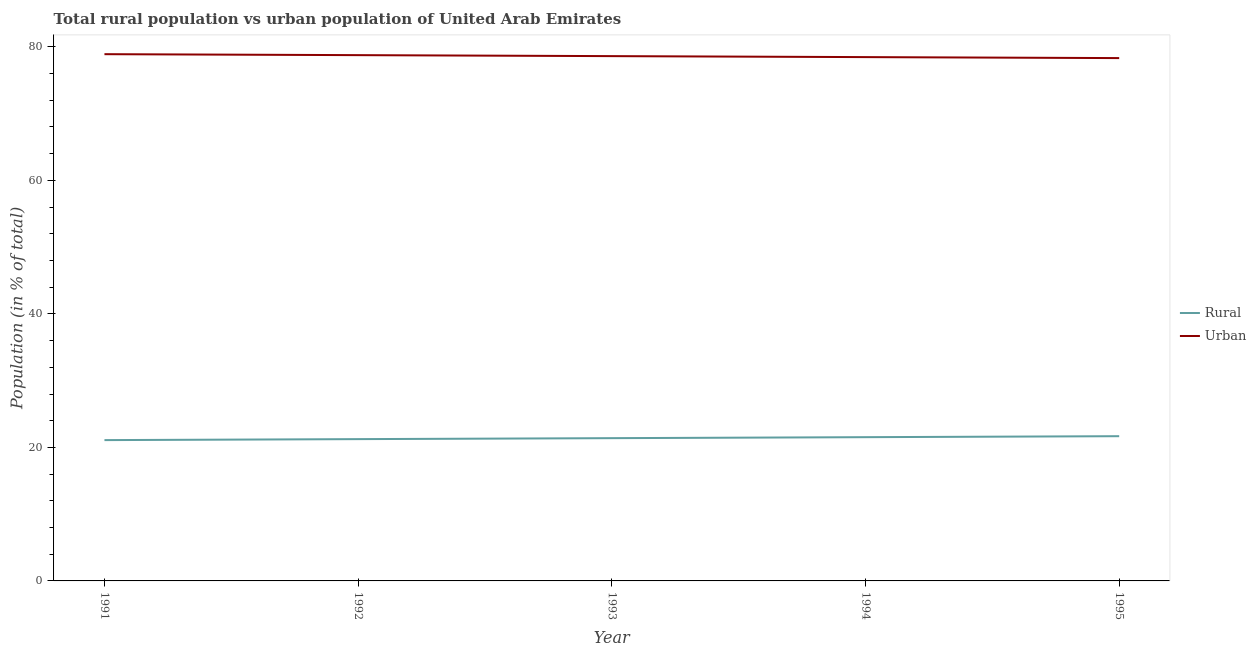What is the urban population in 1993?
Provide a succinct answer. 78.61. Across all years, what is the maximum urban population?
Your response must be concise. 78.91. Across all years, what is the minimum urban population?
Offer a very short reply. 78.32. In which year was the urban population maximum?
Provide a short and direct response. 1991. What is the total rural population in the graph?
Your answer should be very brief. 106.93. What is the difference between the urban population in 1991 and that in 1995?
Offer a terse response. 0.59. What is the difference between the rural population in 1991 and the urban population in 1993?
Your answer should be compact. -57.52. What is the average urban population per year?
Offer a very short reply. 78.61. In the year 1994, what is the difference between the urban population and rural population?
Offer a very short reply. 56.93. In how many years, is the urban population greater than 76 %?
Keep it short and to the point. 5. What is the ratio of the rural population in 1993 to that in 1995?
Ensure brevity in your answer.  0.99. Is the difference between the urban population in 1991 and 1992 greater than the difference between the rural population in 1991 and 1992?
Make the answer very short. Yes. What is the difference between the highest and the second highest urban population?
Provide a succinct answer. 0.15. What is the difference between the highest and the lowest rural population?
Offer a terse response. 0.59. In how many years, is the rural population greater than the average rural population taken over all years?
Keep it short and to the point. 2. Does the rural population monotonically increase over the years?
Provide a succinct answer. Yes. Is the rural population strictly greater than the urban population over the years?
Provide a succinct answer. No. How many lines are there?
Provide a short and direct response. 2. How many years are there in the graph?
Your response must be concise. 5. What is the difference between two consecutive major ticks on the Y-axis?
Give a very brief answer. 20. Are the values on the major ticks of Y-axis written in scientific E-notation?
Your response must be concise. No. Where does the legend appear in the graph?
Keep it short and to the point. Center right. What is the title of the graph?
Provide a short and direct response. Total rural population vs urban population of United Arab Emirates. What is the label or title of the Y-axis?
Your response must be concise. Population (in % of total). What is the Population (in % of total) of Rural in 1991?
Give a very brief answer. 21.09. What is the Population (in % of total) in Urban in 1991?
Your response must be concise. 78.91. What is the Population (in % of total) in Rural in 1992?
Offer a terse response. 21.24. What is the Population (in % of total) in Urban in 1992?
Your answer should be very brief. 78.76. What is the Population (in % of total) of Rural in 1993?
Keep it short and to the point. 21.39. What is the Population (in % of total) in Urban in 1993?
Your response must be concise. 78.61. What is the Population (in % of total) of Rural in 1994?
Offer a very short reply. 21.53. What is the Population (in % of total) in Urban in 1994?
Offer a very short reply. 78.47. What is the Population (in % of total) in Rural in 1995?
Your response must be concise. 21.68. What is the Population (in % of total) of Urban in 1995?
Ensure brevity in your answer.  78.32. Across all years, what is the maximum Population (in % of total) of Rural?
Provide a short and direct response. 21.68. Across all years, what is the maximum Population (in % of total) of Urban?
Keep it short and to the point. 78.91. Across all years, what is the minimum Population (in % of total) of Rural?
Provide a succinct answer. 21.09. Across all years, what is the minimum Population (in % of total) in Urban?
Your answer should be compact. 78.32. What is the total Population (in % of total) in Rural in the graph?
Your response must be concise. 106.93. What is the total Population (in % of total) in Urban in the graph?
Provide a succinct answer. 393.07. What is the difference between the Population (in % of total) in Rural in 1991 and that in 1992?
Make the answer very short. -0.15. What is the difference between the Population (in % of total) in Urban in 1991 and that in 1992?
Offer a very short reply. 0.15. What is the difference between the Population (in % of total) in Rural in 1991 and that in 1993?
Your answer should be compact. -0.29. What is the difference between the Population (in % of total) of Urban in 1991 and that in 1993?
Give a very brief answer. 0.29. What is the difference between the Population (in % of total) in Rural in 1991 and that in 1994?
Offer a very short reply. -0.44. What is the difference between the Population (in % of total) in Urban in 1991 and that in 1994?
Your response must be concise. 0.44. What is the difference between the Population (in % of total) in Rural in 1991 and that in 1995?
Provide a short and direct response. -0.59. What is the difference between the Population (in % of total) of Urban in 1991 and that in 1995?
Provide a short and direct response. 0.59. What is the difference between the Population (in % of total) of Rural in 1992 and that in 1993?
Offer a very short reply. -0.15. What is the difference between the Population (in % of total) in Urban in 1992 and that in 1993?
Your answer should be compact. 0.15. What is the difference between the Population (in % of total) in Rural in 1992 and that in 1994?
Your answer should be compact. -0.29. What is the difference between the Population (in % of total) in Urban in 1992 and that in 1994?
Provide a succinct answer. 0.29. What is the difference between the Population (in % of total) in Rural in 1992 and that in 1995?
Give a very brief answer. -0.44. What is the difference between the Population (in % of total) in Urban in 1992 and that in 1995?
Offer a terse response. 0.44. What is the difference between the Population (in % of total) of Rural in 1993 and that in 1994?
Give a very brief answer. -0.15. What is the difference between the Population (in % of total) of Urban in 1993 and that in 1994?
Ensure brevity in your answer.  0.15. What is the difference between the Population (in % of total) of Rural in 1993 and that in 1995?
Ensure brevity in your answer.  -0.29. What is the difference between the Population (in % of total) in Urban in 1993 and that in 1995?
Your answer should be compact. 0.29. What is the difference between the Population (in % of total) of Rural in 1994 and that in 1995?
Keep it short and to the point. -0.15. What is the difference between the Population (in % of total) in Urban in 1994 and that in 1995?
Your response must be concise. 0.15. What is the difference between the Population (in % of total) in Rural in 1991 and the Population (in % of total) in Urban in 1992?
Give a very brief answer. -57.67. What is the difference between the Population (in % of total) of Rural in 1991 and the Population (in % of total) of Urban in 1993?
Offer a terse response. -57.52. What is the difference between the Population (in % of total) in Rural in 1991 and the Population (in % of total) in Urban in 1994?
Provide a short and direct response. -57.37. What is the difference between the Population (in % of total) of Rural in 1991 and the Population (in % of total) of Urban in 1995?
Make the answer very short. -57.23. What is the difference between the Population (in % of total) of Rural in 1992 and the Population (in % of total) of Urban in 1993?
Your answer should be compact. -57.37. What is the difference between the Population (in % of total) in Rural in 1992 and the Population (in % of total) in Urban in 1994?
Your response must be concise. -57.23. What is the difference between the Population (in % of total) in Rural in 1992 and the Population (in % of total) in Urban in 1995?
Offer a terse response. -57.08. What is the difference between the Population (in % of total) of Rural in 1993 and the Population (in % of total) of Urban in 1994?
Make the answer very short. -57.08. What is the difference between the Population (in % of total) of Rural in 1993 and the Population (in % of total) of Urban in 1995?
Ensure brevity in your answer.  -56.93. What is the difference between the Population (in % of total) in Rural in 1994 and the Population (in % of total) in Urban in 1995?
Your answer should be very brief. -56.79. What is the average Population (in % of total) in Rural per year?
Provide a short and direct response. 21.39. What is the average Population (in % of total) of Urban per year?
Ensure brevity in your answer.  78.61. In the year 1991, what is the difference between the Population (in % of total) in Rural and Population (in % of total) in Urban?
Offer a terse response. -57.81. In the year 1992, what is the difference between the Population (in % of total) of Rural and Population (in % of total) of Urban?
Ensure brevity in your answer.  -57.52. In the year 1993, what is the difference between the Population (in % of total) in Rural and Population (in % of total) in Urban?
Offer a terse response. -57.23. In the year 1994, what is the difference between the Population (in % of total) in Rural and Population (in % of total) in Urban?
Your answer should be compact. -56.93. In the year 1995, what is the difference between the Population (in % of total) of Rural and Population (in % of total) of Urban?
Offer a terse response. -56.64. What is the ratio of the Population (in % of total) in Rural in 1991 to that in 1993?
Give a very brief answer. 0.99. What is the ratio of the Population (in % of total) in Rural in 1991 to that in 1994?
Your answer should be very brief. 0.98. What is the ratio of the Population (in % of total) of Urban in 1991 to that in 1994?
Give a very brief answer. 1.01. What is the ratio of the Population (in % of total) in Rural in 1991 to that in 1995?
Make the answer very short. 0.97. What is the ratio of the Population (in % of total) in Urban in 1991 to that in 1995?
Your answer should be very brief. 1.01. What is the ratio of the Population (in % of total) in Urban in 1992 to that in 1993?
Make the answer very short. 1. What is the ratio of the Population (in % of total) of Rural in 1992 to that in 1994?
Give a very brief answer. 0.99. What is the ratio of the Population (in % of total) of Rural in 1992 to that in 1995?
Your response must be concise. 0.98. What is the ratio of the Population (in % of total) in Urban in 1992 to that in 1995?
Make the answer very short. 1.01. What is the ratio of the Population (in % of total) of Rural in 1993 to that in 1994?
Provide a short and direct response. 0.99. What is the ratio of the Population (in % of total) of Rural in 1993 to that in 1995?
Your answer should be very brief. 0.99. What is the ratio of the Population (in % of total) of Urban in 1993 to that in 1995?
Your answer should be very brief. 1. What is the difference between the highest and the second highest Population (in % of total) of Rural?
Make the answer very short. 0.15. What is the difference between the highest and the second highest Population (in % of total) in Urban?
Keep it short and to the point. 0.15. What is the difference between the highest and the lowest Population (in % of total) in Rural?
Your answer should be compact. 0.59. What is the difference between the highest and the lowest Population (in % of total) in Urban?
Give a very brief answer. 0.59. 